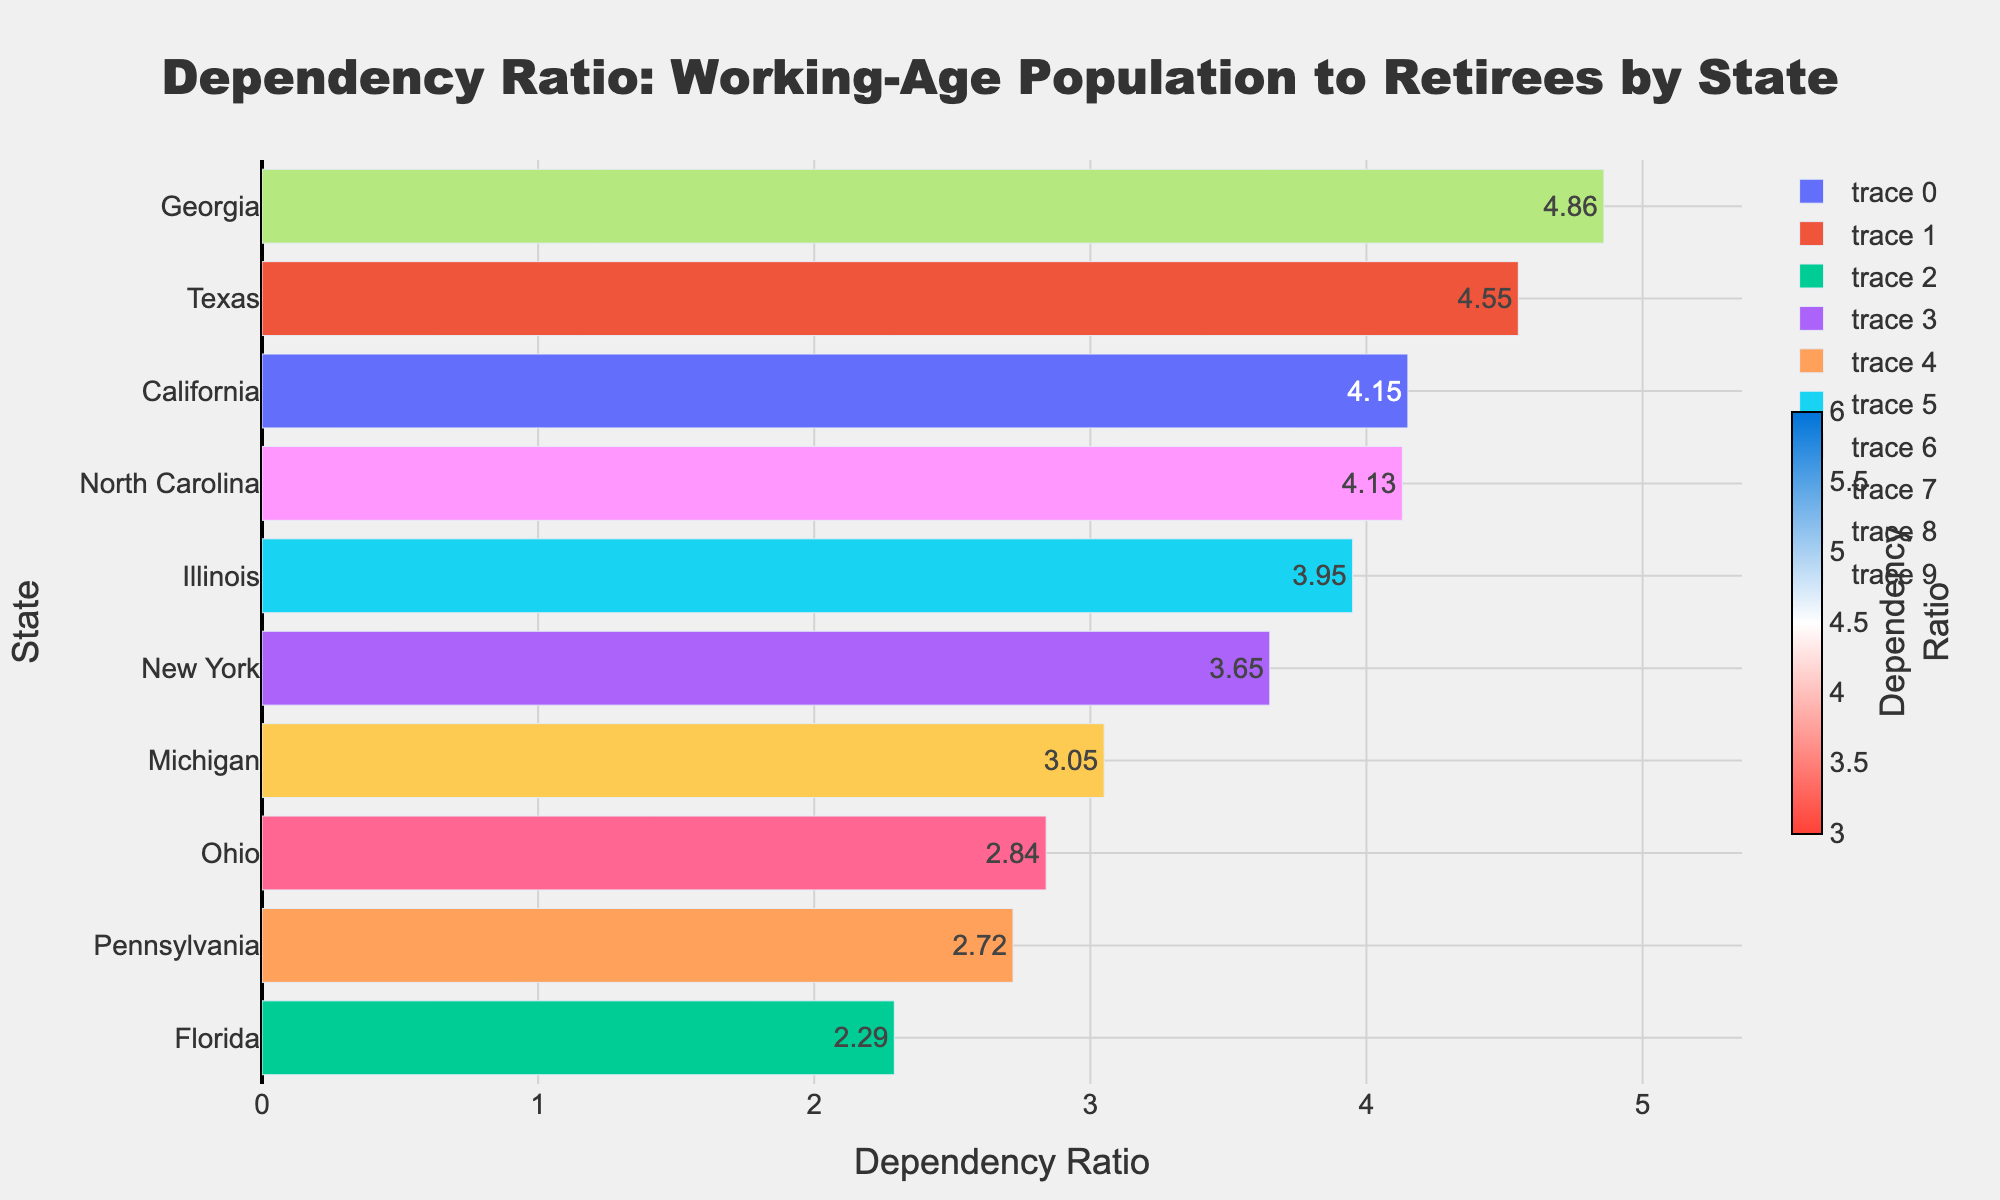Which state has the highest dependency ratio? The figure shows each state's dependency ratio as a horizontally oriented bar, with numerical values directly labeled on the bars. The state with the longest red-colored bar at the topmost position represents the highest dependency ratio. Based on the chart, Georgia has the highest dependency ratio of 4.86.
Answer: Georgia Which state has the lowest dependency ratio? The state with the shortest blue-colored bar will have the lowest dependency ratio. Looking at the bars and their values, Florida has the lowest dependency ratio of 2.29.
Answer: Florida Which states have a dependency ratio greater than 4? We need to look for bars that extend beyond the value 4 on the x-axis. The states that have bars extending beyond this threshold are Georgia, Texas, and California, with dependency ratios of 4.86, 4.55, and 4.15, respectively.
Answer: Georgia, Texas, California How does the dependency ratio of New York compare with that of Michigan? By comparing the lengths of the bars and their numerical values, New York's dependency ratio is 3.65, whereas Michigan's is 3.05. New York has a higher dependency ratio compared to Michigan by 0.60.
Answer: New York's ratio is higher by 0.60 What's the average dependency ratio of all the states? To calculate the average, sum up all the dependency ratios of the states and divide by the number of states: (4.15+4.55+2.29+3.65+2.72+3.95+2.84+4.86+4.13+3.05) / 10 = 3.619.
Answer: 3.62 Which state has a dependency ratio closest to the median of all states? First, calculate the median of the dependency ratios: arrange them in order (2.29, 2.72, 2.84, 3.05, 3.65, 3.95, 4.13, 4.15, 4.55, 4.86). The median is (3.65 + 3.95) / 2 = 3.80. The state closest to this median dependency ratio in the bar chart is Illinois with a dependency ratio of 3.95.
Answer: Illinois What's the combined dependency ratio of the top two states? Georgia and Texas have the highest dependency ratios of 4.86 and 4.55, respectively. Adding these together results in 4.86 + 4.55 = 9.41.
Answer: 9.41 